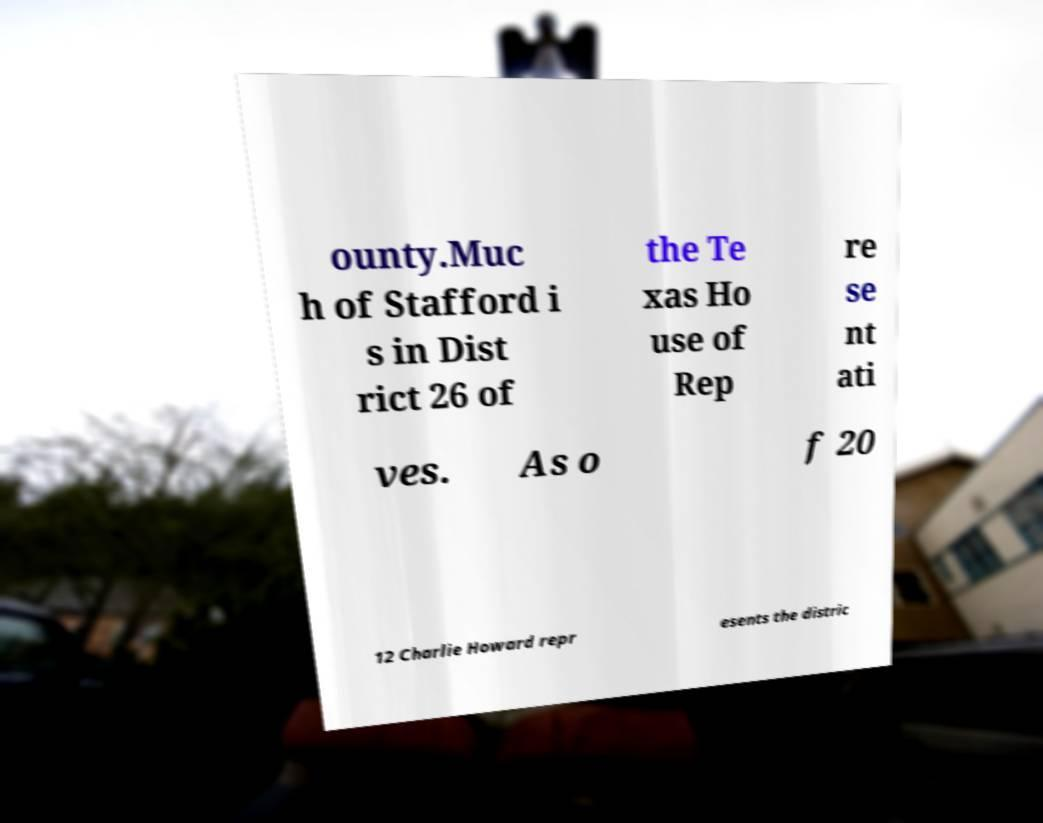I need the written content from this picture converted into text. Can you do that? ounty.Muc h of Stafford i s in Dist rict 26 of the Te xas Ho use of Rep re se nt ati ves. As o f 20 12 Charlie Howard repr esents the distric 